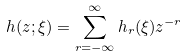Convert formula to latex. <formula><loc_0><loc_0><loc_500><loc_500>h ( z ; \xi ) = \sum _ { r = - \infty } ^ { \infty } h _ { r } ( \xi ) z ^ { - r }</formula> 